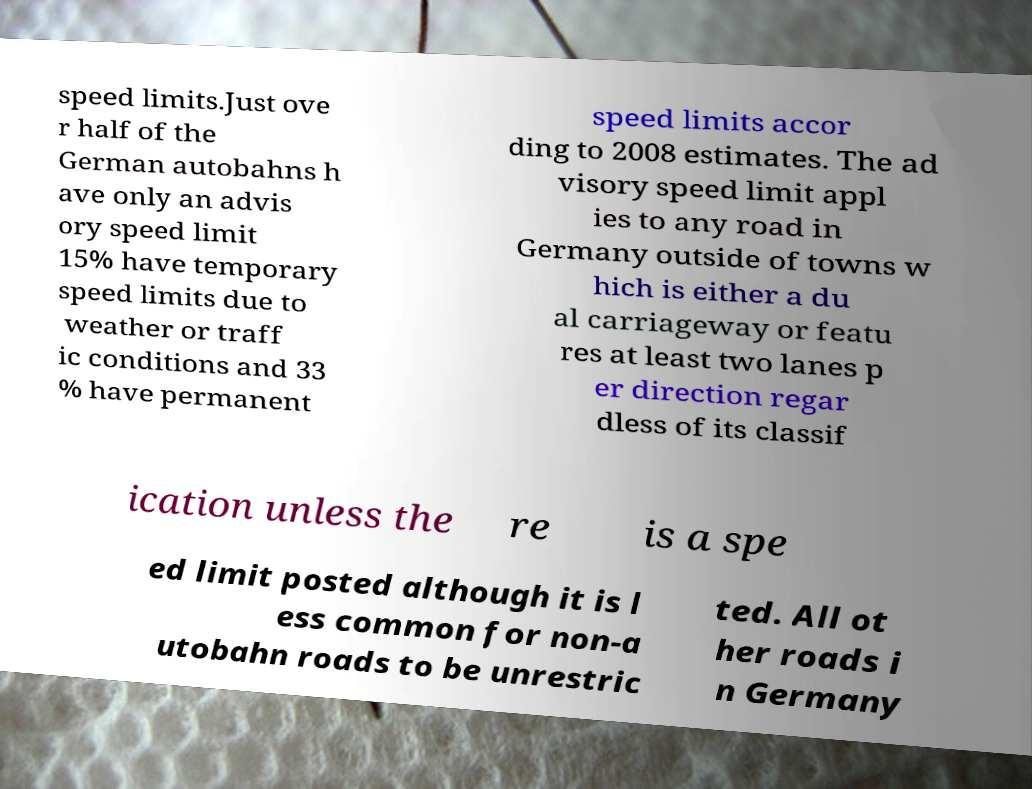Please identify and transcribe the text found in this image. speed limits.Just ove r half of the German autobahns h ave only an advis ory speed limit 15% have temporary speed limits due to weather or traff ic conditions and 33 % have permanent speed limits accor ding to 2008 estimates. The ad visory speed limit appl ies to any road in Germany outside of towns w hich is either a du al carriageway or featu res at least two lanes p er direction regar dless of its classif ication unless the re is a spe ed limit posted although it is l ess common for non-a utobahn roads to be unrestric ted. All ot her roads i n Germany 